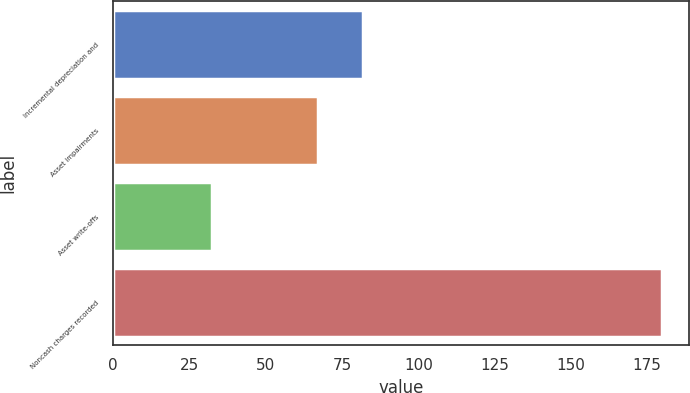Convert chart. <chart><loc_0><loc_0><loc_500><loc_500><bar_chart><fcel>Incremental depreciation and<fcel>Asset impairments<fcel>Asset write-offs<fcel>Noncash charges recorded<nl><fcel>81.93<fcel>67.2<fcel>32.4<fcel>179.7<nl></chart> 